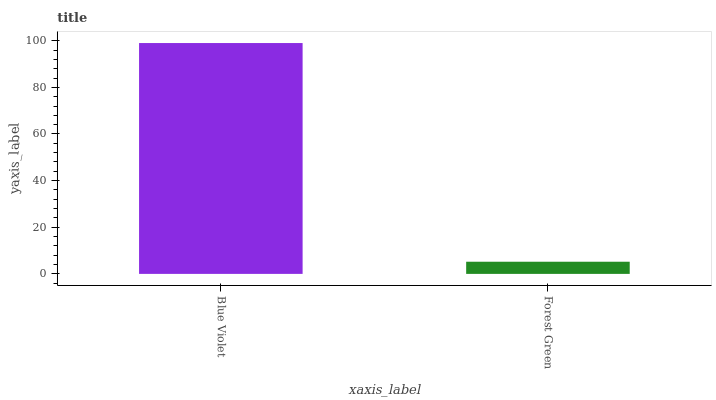Is Forest Green the minimum?
Answer yes or no. Yes. Is Blue Violet the maximum?
Answer yes or no. Yes. Is Forest Green the maximum?
Answer yes or no. No. Is Blue Violet greater than Forest Green?
Answer yes or no. Yes. Is Forest Green less than Blue Violet?
Answer yes or no. Yes. Is Forest Green greater than Blue Violet?
Answer yes or no. No. Is Blue Violet less than Forest Green?
Answer yes or no. No. Is Blue Violet the high median?
Answer yes or no. Yes. Is Forest Green the low median?
Answer yes or no. Yes. Is Forest Green the high median?
Answer yes or no. No. Is Blue Violet the low median?
Answer yes or no. No. 